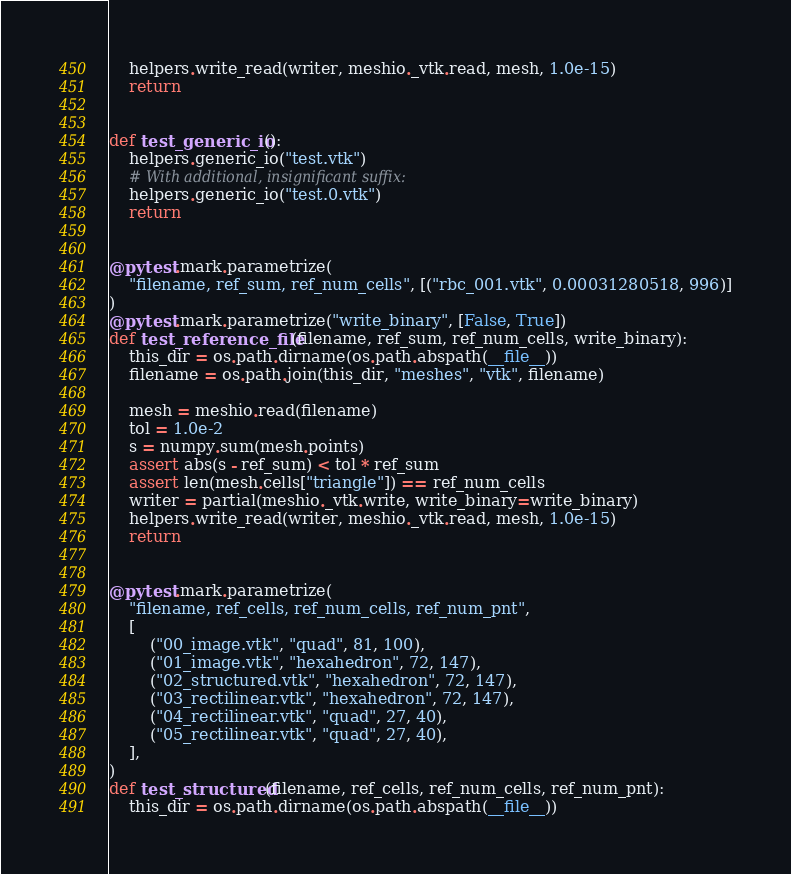<code> <loc_0><loc_0><loc_500><loc_500><_Python_>
    helpers.write_read(writer, meshio._vtk.read, mesh, 1.0e-15)
    return


def test_generic_io():
    helpers.generic_io("test.vtk")
    # With additional, insignificant suffix:
    helpers.generic_io("test.0.vtk")
    return


@pytest.mark.parametrize(
    "filename, ref_sum, ref_num_cells", [("rbc_001.vtk", 0.00031280518, 996)]
)
@pytest.mark.parametrize("write_binary", [False, True])
def test_reference_file(filename, ref_sum, ref_num_cells, write_binary):
    this_dir = os.path.dirname(os.path.abspath(__file__))
    filename = os.path.join(this_dir, "meshes", "vtk", filename)

    mesh = meshio.read(filename)
    tol = 1.0e-2
    s = numpy.sum(mesh.points)
    assert abs(s - ref_sum) < tol * ref_sum
    assert len(mesh.cells["triangle"]) == ref_num_cells
    writer = partial(meshio._vtk.write, write_binary=write_binary)
    helpers.write_read(writer, meshio._vtk.read, mesh, 1.0e-15)
    return


@pytest.mark.parametrize(
    "filename, ref_cells, ref_num_cells, ref_num_pnt",
    [
        ("00_image.vtk", "quad", 81, 100),
        ("01_image.vtk", "hexahedron", 72, 147),
        ("02_structured.vtk", "hexahedron", 72, 147),
        ("03_rectilinear.vtk", "hexahedron", 72, 147),
        ("04_rectilinear.vtk", "quad", 27, 40),
        ("05_rectilinear.vtk", "quad", 27, 40),
    ],
)
def test_structured(filename, ref_cells, ref_num_cells, ref_num_pnt):
    this_dir = os.path.dirname(os.path.abspath(__file__))</code> 